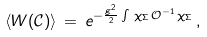Convert formula to latex. <formula><loc_0><loc_0><loc_500><loc_500>\langle W ( { \mathcal { C } } ) \rangle \, = \, e ^ { - \frac { g ^ { 2 } } { 2 } \int \, \chi _ { \Sigma } \, { \mathcal { O } } ^ { - 1 } \, \chi _ { \Sigma } } \, ,</formula> 